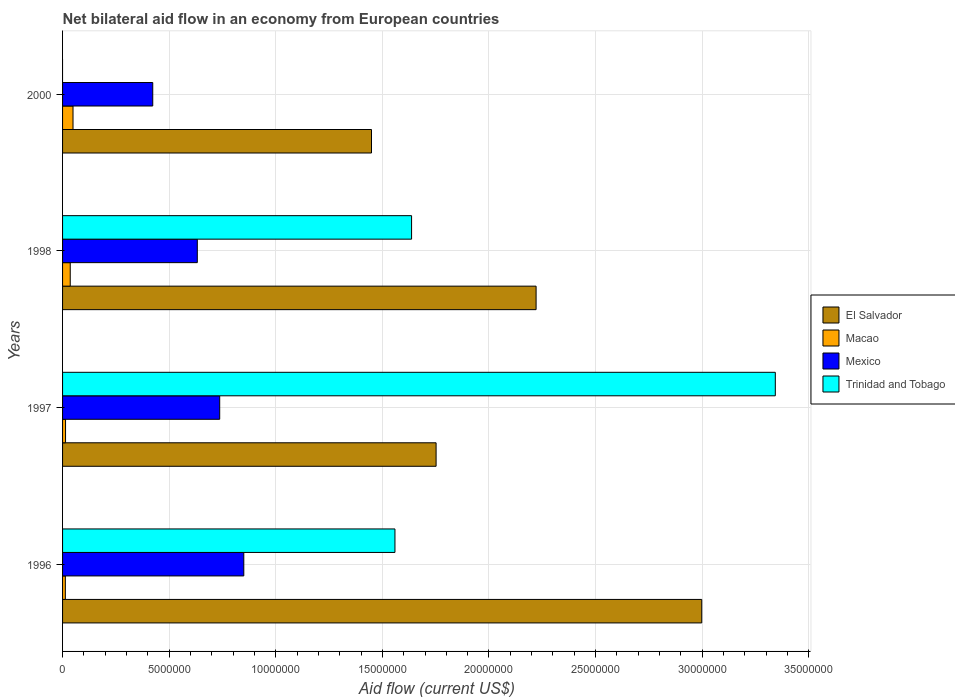How many groups of bars are there?
Your response must be concise. 4. How many bars are there on the 4th tick from the top?
Keep it short and to the point. 4. What is the net bilateral aid flow in Trinidad and Tobago in 1998?
Your answer should be compact. 1.64e+07. Across all years, what is the maximum net bilateral aid flow in Trinidad and Tobago?
Your answer should be compact. 3.34e+07. Across all years, what is the minimum net bilateral aid flow in El Salvador?
Make the answer very short. 1.45e+07. In which year was the net bilateral aid flow in Mexico maximum?
Your answer should be compact. 1996. What is the total net bilateral aid flow in Macao in the graph?
Offer a very short reply. 1.12e+06. What is the difference between the net bilateral aid flow in Macao in 1996 and that in 2000?
Make the answer very short. -3.60e+05. What is the difference between the net bilateral aid flow in Macao in 1998 and the net bilateral aid flow in Trinidad and Tobago in 1997?
Your answer should be very brief. -3.31e+07. What is the average net bilateral aid flow in Trinidad and Tobago per year?
Your answer should be very brief. 1.63e+07. In the year 2000, what is the difference between the net bilateral aid flow in Mexico and net bilateral aid flow in El Salvador?
Ensure brevity in your answer.  -1.03e+07. What is the ratio of the net bilateral aid flow in Macao in 1996 to that in 1997?
Make the answer very short. 0.93. Is the net bilateral aid flow in Mexico in 1997 less than that in 2000?
Offer a very short reply. No. What is the difference between the highest and the lowest net bilateral aid flow in Mexico?
Make the answer very short. 4.27e+06. In how many years, is the net bilateral aid flow in Mexico greater than the average net bilateral aid flow in Mexico taken over all years?
Make the answer very short. 2. Are all the bars in the graph horizontal?
Your response must be concise. Yes. How many years are there in the graph?
Your response must be concise. 4. What is the difference between two consecutive major ticks on the X-axis?
Offer a very short reply. 5.00e+06. Where does the legend appear in the graph?
Provide a succinct answer. Center right. How many legend labels are there?
Your answer should be compact. 4. What is the title of the graph?
Ensure brevity in your answer.  Net bilateral aid flow in an economy from European countries. What is the label or title of the X-axis?
Provide a succinct answer. Aid flow (current US$). What is the label or title of the Y-axis?
Provide a succinct answer. Years. What is the Aid flow (current US$) of El Salvador in 1996?
Offer a terse response. 3.00e+07. What is the Aid flow (current US$) of Mexico in 1996?
Keep it short and to the point. 8.50e+06. What is the Aid flow (current US$) of Trinidad and Tobago in 1996?
Ensure brevity in your answer.  1.56e+07. What is the Aid flow (current US$) in El Salvador in 1997?
Provide a succinct answer. 1.75e+07. What is the Aid flow (current US$) in Macao in 1997?
Your answer should be compact. 1.40e+05. What is the Aid flow (current US$) of Mexico in 1997?
Make the answer very short. 7.37e+06. What is the Aid flow (current US$) of Trinidad and Tobago in 1997?
Provide a short and direct response. 3.34e+07. What is the Aid flow (current US$) of El Salvador in 1998?
Provide a succinct answer. 2.22e+07. What is the Aid flow (current US$) of Mexico in 1998?
Make the answer very short. 6.32e+06. What is the Aid flow (current US$) in Trinidad and Tobago in 1998?
Your answer should be compact. 1.64e+07. What is the Aid flow (current US$) of El Salvador in 2000?
Keep it short and to the point. 1.45e+07. What is the Aid flow (current US$) of Macao in 2000?
Ensure brevity in your answer.  4.90e+05. What is the Aid flow (current US$) of Mexico in 2000?
Offer a very short reply. 4.23e+06. Across all years, what is the maximum Aid flow (current US$) in El Salvador?
Provide a succinct answer. 3.00e+07. Across all years, what is the maximum Aid flow (current US$) in Macao?
Give a very brief answer. 4.90e+05. Across all years, what is the maximum Aid flow (current US$) in Mexico?
Ensure brevity in your answer.  8.50e+06. Across all years, what is the maximum Aid flow (current US$) in Trinidad and Tobago?
Provide a short and direct response. 3.34e+07. Across all years, what is the minimum Aid flow (current US$) in El Salvador?
Your answer should be very brief. 1.45e+07. Across all years, what is the minimum Aid flow (current US$) in Macao?
Ensure brevity in your answer.  1.30e+05. Across all years, what is the minimum Aid flow (current US$) in Mexico?
Your answer should be very brief. 4.23e+06. What is the total Aid flow (current US$) of El Salvador in the graph?
Keep it short and to the point. 8.42e+07. What is the total Aid flow (current US$) in Macao in the graph?
Make the answer very short. 1.12e+06. What is the total Aid flow (current US$) in Mexico in the graph?
Provide a short and direct response. 2.64e+07. What is the total Aid flow (current US$) in Trinidad and Tobago in the graph?
Make the answer very short. 6.54e+07. What is the difference between the Aid flow (current US$) in El Salvador in 1996 and that in 1997?
Ensure brevity in your answer.  1.25e+07. What is the difference between the Aid flow (current US$) of Macao in 1996 and that in 1997?
Provide a short and direct response. -10000. What is the difference between the Aid flow (current US$) in Mexico in 1996 and that in 1997?
Offer a very short reply. 1.13e+06. What is the difference between the Aid flow (current US$) in Trinidad and Tobago in 1996 and that in 1997?
Keep it short and to the point. -1.78e+07. What is the difference between the Aid flow (current US$) in El Salvador in 1996 and that in 1998?
Keep it short and to the point. 7.77e+06. What is the difference between the Aid flow (current US$) in Mexico in 1996 and that in 1998?
Make the answer very short. 2.18e+06. What is the difference between the Aid flow (current US$) of Trinidad and Tobago in 1996 and that in 1998?
Offer a terse response. -7.80e+05. What is the difference between the Aid flow (current US$) in El Salvador in 1996 and that in 2000?
Give a very brief answer. 1.55e+07. What is the difference between the Aid flow (current US$) in Macao in 1996 and that in 2000?
Provide a short and direct response. -3.60e+05. What is the difference between the Aid flow (current US$) of Mexico in 1996 and that in 2000?
Offer a terse response. 4.27e+06. What is the difference between the Aid flow (current US$) of El Salvador in 1997 and that in 1998?
Keep it short and to the point. -4.69e+06. What is the difference between the Aid flow (current US$) of Mexico in 1997 and that in 1998?
Ensure brevity in your answer.  1.05e+06. What is the difference between the Aid flow (current US$) in Trinidad and Tobago in 1997 and that in 1998?
Offer a terse response. 1.71e+07. What is the difference between the Aid flow (current US$) in El Salvador in 1997 and that in 2000?
Provide a short and direct response. 3.03e+06. What is the difference between the Aid flow (current US$) in Macao in 1997 and that in 2000?
Your response must be concise. -3.50e+05. What is the difference between the Aid flow (current US$) of Mexico in 1997 and that in 2000?
Ensure brevity in your answer.  3.14e+06. What is the difference between the Aid flow (current US$) of El Salvador in 1998 and that in 2000?
Provide a succinct answer. 7.72e+06. What is the difference between the Aid flow (current US$) in Mexico in 1998 and that in 2000?
Provide a short and direct response. 2.09e+06. What is the difference between the Aid flow (current US$) of El Salvador in 1996 and the Aid flow (current US$) of Macao in 1997?
Your answer should be very brief. 2.98e+07. What is the difference between the Aid flow (current US$) of El Salvador in 1996 and the Aid flow (current US$) of Mexico in 1997?
Ensure brevity in your answer.  2.26e+07. What is the difference between the Aid flow (current US$) in El Salvador in 1996 and the Aid flow (current US$) in Trinidad and Tobago in 1997?
Provide a succinct answer. -3.45e+06. What is the difference between the Aid flow (current US$) of Macao in 1996 and the Aid flow (current US$) of Mexico in 1997?
Make the answer very short. -7.24e+06. What is the difference between the Aid flow (current US$) in Macao in 1996 and the Aid flow (current US$) in Trinidad and Tobago in 1997?
Your answer should be very brief. -3.33e+07. What is the difference between the Aid flow (current US$) in Mexico in 1996 and the Aid flow (current US$) in Trinidad and Tobago in 1997?
Offer a very short reply. -2.49e+07. What is the difference between the Aid flow (current US$) of El Salvador in 1996 and the Aid flow (current US$) of Macao in 1998?
Give a very brief answer. 2.96e+07. What is the difference between the Aid flow (current US$) of El Salvador in 1996 and the Aid flow (current US$) of Mexico in 1998?
Give a very brief answer. 2.37e+07. What is the difference between the Aid flow (current US$) in El Salvador in 1996 and the Aid flow (current US$) in Trinidad and Tobago in 1998?
Offer a terse response. 1.36e+07. What is the difference between the Aid flow (current US$) in Macao in 1996 and the Aid flow (current US$) in Mexico in 1998?
Offer a terse response. -6.19e+06. What is the difference between the Aid flow (current US$) of Macao in 1996 and the Aid flow (current US$) of Trinidad and Tobago in 1998?
Your answer should be compact. -1.62e+07. What is the difference between the Aid flow (current US$) of Mexico in 1996 and the Aid flow (current US$) of Trinidad and Tobago in 1998?
Provide a short and direct response. -7.87e+06. What is the difference between the Aid flow (current US$) in El Salvador in 1996 and the Aid flow (current US$) in Macao in 2000?
Make the answer very short. 2.95e+07. What is the difference between the Aid flow (current US$) in El Salvador in 1996 and the Aid flow (current US$) in Mexico in 2000?
Your answer should be very brief. 2.58e+07. What is the difference between the Aid flow (current US$) in Macao in 1996 and the Aid flow (current US$) in Mexico in 2000?
Keep it short and to the point. -4.10e+06. What is the difference between the Aid flow (current US$) in El Salvador in 1997 and the Aid flow (current US$) in Macao in 1998?
Your answer should be compact. 1.72e+07. What is the difference between the Aid flow (current US$) in El Salvador in 1997 and the Aid flow (current US$) in Mexico in 1998?
Offer a terse response. 1.12e+07. What is the difference between the Aid flow (current US$) in El Salvador in 1997 and the Aid flow (current US$) in Trinidad and Tobago in 1998?
Offer a terse response. 1.15e+06. What is the difference between the Aid flow (current US$) of Macao in 1997 and the Aid flow (current US$) of Mexico in 1998?
Ensure brevity in your answer.  -6.18e+06. What is the difference between the Aid flow (current US$) in Macao in 1997 and the Aid flow (current US$) in Trinidad and Tobago in 1998?
Provide a succinct answer. -1.62e+07. What is the difference between the Aid flow (current US$) of Mexico in 1997 and the Aid flow (current US$) of Trinidad and Tobago in 1998?
Provide a succinct answer. -9.00e+06. What is the difference between the Aid flow (current US$) in El Salvador in 1997 and the Aid flow (current US$) in Macao in 2000?
Your answer should be compact. 1.70e+07. What is the difference between the Aid flow (current US$) of El Salvador in 1997 and the Aid flow (current US$) of Mexico in 2000?
Give a very brief answer. 1.33e+07. What is the difference between the Aid flow (current US$) of Macao in 1997 and the Aid flow (current US$) of Mexico in 2000?
Keep it short and to the point. -4.09e+06. What is the difference between the Aid flow (current US$) in El Salvador in 1998 and the Aid flow (current US$) in Macao in 2000?
Your answer should be very brief. 2.17e+07. What is the difference between the Aid flow (current US$) in El Salvador in 1998 and the Aid flow (current US$) in Mexico in 2000?
Offer a terse response. 1.80e+07. What is the difference between the Aid flow (current US$) in Macao in 1998 and the Aid flow (current US$) in Mexico in 2000?
Your response must be concise. -3.87e+06. What is the average Aid flow (current US$) of El Salvador per year?
Provide a short and direct response. 2.10e+07. What is the average Aid flow (current US$) of Macao per year?
Provide a short and direct response. 2.80e+05. What is the average Aid flow (current US$) in Mexico per year?
Provide a succinct answer. 6.60e+06. What is the average Aid flow (current US$) in Trinidad and Tobago per year?
Keep it short and to the point. 1.63e+07. In the year 1996, what is the difference between the Aid flow (current US$) of El Salvador and Aid flow (current US$) of Macao?
Your answer should be compact. 2.98e+07. In the year 1996, what is the difference between the Aid flow (current US$) in El Salvador and Aid flow (current US$) in Mexico?
Keep it short and to the point. 2.15e+07. In the year 1996, what is the difference between the Aid flow (current US$) in El Salvador and Aid flow (current US$) in Trinidad and Tobago?
Offer a terse response. 1.44e+07. In the year 1996, what is the difference between the Aid flow (current US$) of Macao and Aid flow (current US$) of Mexico?
Offer a very short reply. -8.37e+06. In the year 1996, what is the difference between the Aid flow (current US$) of Macao and Aid flow (current US$) of Trinidad and Tobago?
Your answer should be very brief. -1.55e+07. In the year 1996, what is the difference between the Aid flow (current US$) in Mexico and Aid flow (current US$) in Trinidad and Tobago?
Offer a terse response. -7.09e+06. In the year 1997, what is the difference between the Aid flow (current US$) of El Salvador and Aid flow (current US$) of Macao?
Offer a terse response. 1.74e+07. In the year 1997, what is the difference between the Aid flow (current US$) of El Salvador and Aid flow (current US$) of Mexico?
Provide a succinct answer. 1.02e+07. In the year 1997, what is the difference between the Aid flow (current US$) of El Salvador and Aid flow (current US$) of Trinidad and Tobago?
Provide a short and direct response. -1.59e+07. In the year 1997, what is the difference between the Aid flow (current US$) in Macao and Aid flow (current US$) in Mexico?
Offer a terse response. -7.23e+06. In the year 1997, what is the difference between the Aid flow (current US$) in Macao and Aid flow (current US$) in Trinidad and Tobago?
Offer a terse response. -3.33e+07. In the year 1997, what is the difference between the Aid flow (current US$) of Mexico and Aid flow (current US$) of Trinidad and Tobago?
Ensure brevity in your answer.  -2.61e+07. In the year 1998, what is the difference between the Aid flow (current US$) in El Salvador and Aid flow (current US$) in Macao?
Give a very brief answer. 2.18e+07. In the year 1998, what is the difference between the Aid flow (current US$) in El Salvador and Aid flow (current US$) in Mexico?
Offer a terse response. 1.59e+07. In the year 1998, what is the difference between the Aid flow (current US$) of El Salvador and Aid flow (current US$) of Trinidad and Tobago?
Your answer should be compact. 5.84e+06. In the year 1998, what is the difference between the Aid flow (current US$) in Macao and Aid flow (current US$) in Mexico?
Provide a short and direct response. -5.96e+06. In the year 1998, what is the difference between the Aid flow (current US$) in Macao and Aid flow (current US$) in Trinidad and Tobago?
Offer a very short reply. -1.60e+07. In the year 1998, what is the difference between the Aid flow (current US$) in Mexico and Aid flow (current US$) in Trinidad and Tobago?
Make the answer very short. -1.00e+07. In the year 2000, what is the difference between the Aid flow (current US$) of El Salvador and Aid flow (current US$) of Macao?
Provide a succinct answer. 1.40e+07. In the year 2000, what is the difference between the Aid flow (current US$) in El Salvador and Aid flow (current US$) in Mexico?
Make the answer very short. 1.03e+07. In the year 2000, what is the difference between the Aid flow (current US$) in Macao and Aid flow (current US$) in Mexico?
Give a very brief answer. -3.74e+06. What is the ratio of the Aid flow (current US$) of El Salvador in 1996 to that in 1997?
Keep it short and to the point. 1.71. What is the ratio of the Aid flow (current US$) in Macao in 1996 to that in 1997?
Your response must be concise. 0.93. What is the ratio of the Aid flow (current US$) of Mexico in 1996 to that in 1997?
Keep it short and to the point. 1.15. What is the ratio of the Aid flow (current US$) of Trinidad and Tobago in 1996 to that in 1997?
Make the answer very short. 0.47. What is the ratio of the Aid flow (current US$) of El Salvador in 1996 to that in 1998?
Your answer should be compact. 1.35. What is the ratio of the Aid flow (current US$) of Macao in 1996 to that in 1998?
Provide a short and direct response. 0.36. What is the ratio of the Aid flow (current US$) in Mexico in 1996 to that in 1998?
Ensure brevity in your answer.  1.34. What is the ratio of the Aid flow (current US$) in Trinidad and Tobago in 1996 to that in 1998?
Offer a terse response. 0.95. What is the ratio of the Aid flow (current US$) in El Salvador in 1996 to that in 2000?
Your answer should be very brief. 2.07. What is the ratio of the Aid flow (current US$) in Macao in 1996 to that in 2000?
Your answer should be very brief. 0.27. What is the ratio of the Aid flow (current US$) of Mexico in 1996 to that in 2000?
Provide a succinct answer. 2.01. What is the ratio of the Aid flow (current US$) of El Salvador in 1997 to that in 1998?
Keep it short and to the point. 0.79. What is the ratio of the Aid flow (current US$) in Macao in 1997 to that in 1998?
Provide a succinct answer. 0.39. What is the ratio of the Aid flow (current US$) of Mexico in 1997 to that in 1998?
Provide a succinct answer. 1.17. What is the ratio of the Aid flow (current US$) of Trinidad and Tobago in 1997 to that in 1998?
Your response must be concise. 2.04. What is the ratio of the Aid flow (current US$) in El Salvador in 1997 to that in 2000?
Provide a short and direct response. 1.21. What is the ratio of the Aid flow (current US$) in Macao in 1997 to that in 2000?
Keep it short and to the point. 0.29. What is the ratio of the Aid flow (current US$) of Mexico in 1997 to that in 2000?
Make the answer very short. 1.74. What is the ratio of the Aid flow (current US$) in El Salvador in 1998 to that in 2000?
Provide a succinct answer. 1.53. What is the ratio of the Aid flow (current US$) of Macao in 1998 to that in 2000?
Ensure brevity in your answer.  0.73. What is the ratio of the Aid flow (current US$) of Mexico in 1998 to that in 2000?
Offer a very short reply. 1.49. What is the difference between the highest and the second highest Aid flow (current US$) in El Salvador?
Keep it short and to the point. 7.77e+06. What is the difference between the highest and the second highest Aid flow (current US$) in Mexico?
Offer a very short reply. 1.13e+06. What is the difference between the highest and the second highest Aid flow (current US$) of Trinidad and Tobago?
Your response must be concise. 1.71e+07. What is the difference between the highest and the lowest Aid flow (current US$) in El Salvador?
Provide a short and direct response. 1.55e+07. What is the difference between the highest and the lowest Aid flow (current US$) of Mexico?
Your answer should be very brief. 4.27e+06. What is the difference between the highest and the lowest Aid flow (current US$) of Trinidad and Tobago?
Give a very brief answer. 3.34e+07. 